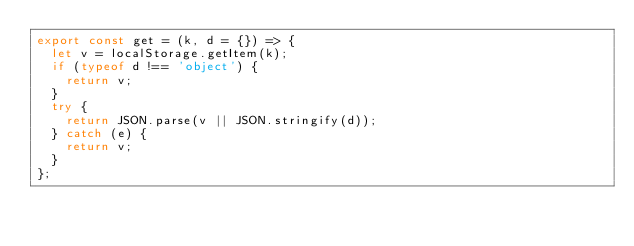Convert code to text. <code><loc_0><loc_0><loc_500><loc_500><_JavaScript_>export const get = (k, d = {}) => {
	let v = localStorage.getItem(k);
	if (typeof d !== 'object') {
		return v;
	}
	try {
		return JSON.parse(v || JSON.stringify(d));
	} catch (e) {
		return v;
	}
};</code> 